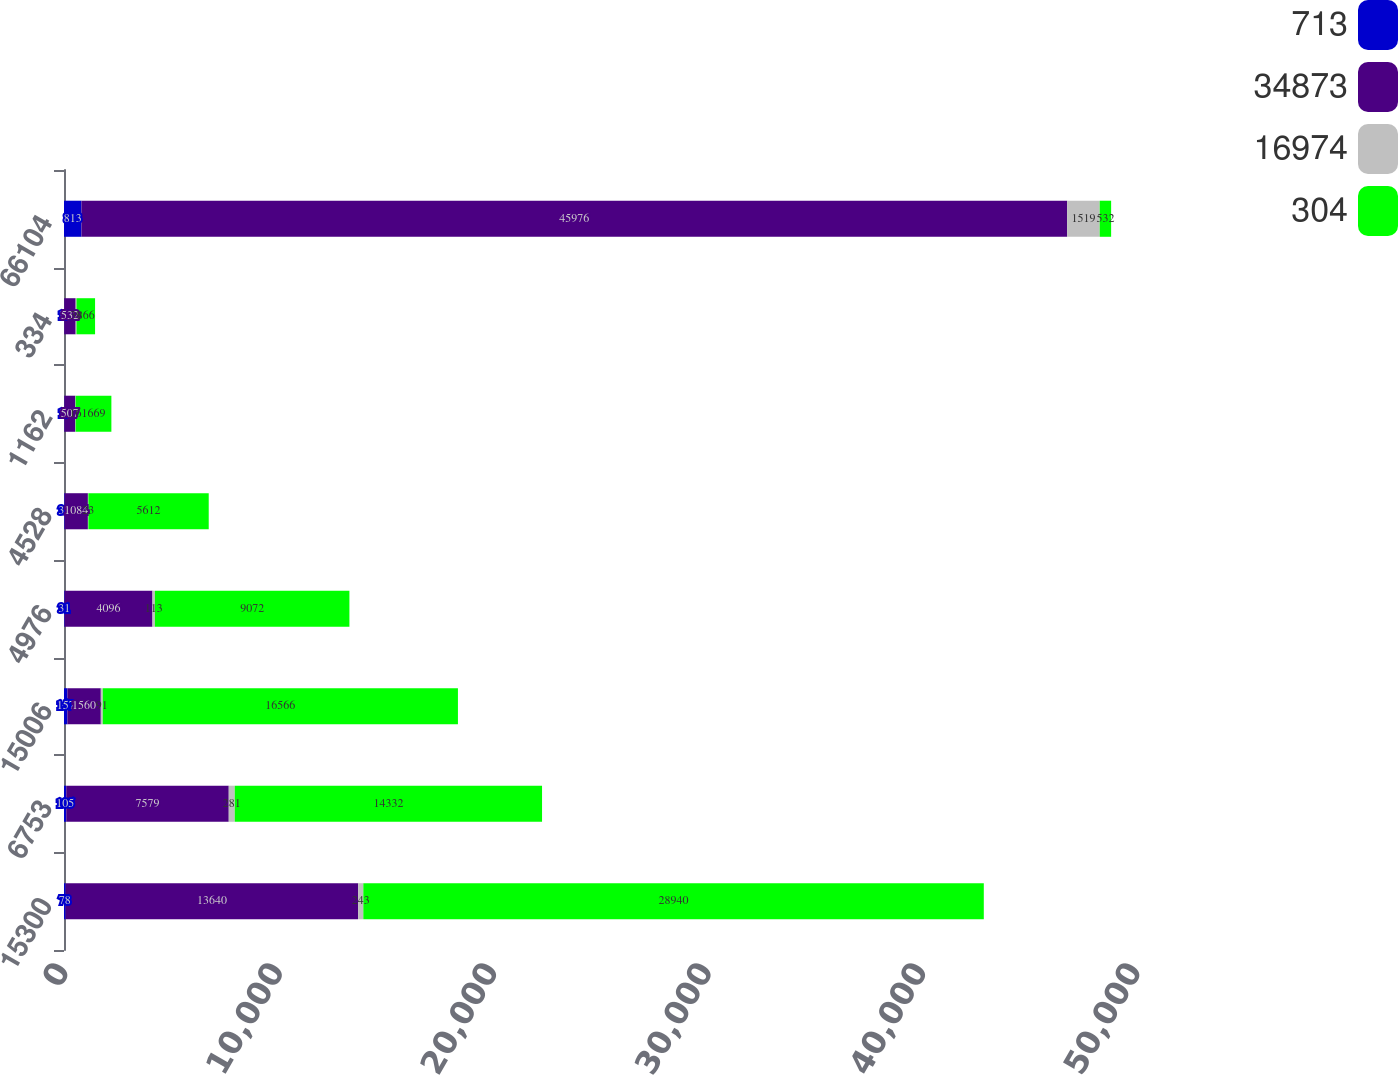Convert chart to OTSL. <chart><loc_0><loc_0><loc_500><loc_500><stacked_bar_chart><ecel><fcel>15300<fcel>6753<fcel>15006<fcel>4976<fcel>4528<fcel>1162<fcel>334<fcel>66104<nl><fcel>713<fcel>78<fcel>105<fcel>157<fcel>31<fcel>31<fcel>18<fcel>12<fcel>813<nl><fcel>34873<fcel>13640<fcel>7579<fcel>1560<fcel>4096<fcel>1084<fcel>507<fcel>532<fcel>45976<nl><fcel>16974<fcel>243<fcel>281<fcel>91<fcel>113<fcel>23<fcel>16<fcel>39<fcel>1519<nl><fcel>304<fcel>28940<fcel>14332<fcel>16566<fcel>9072<fcel>5612<fcel>1669<fcel>866<fcel>532<nl></chart> 